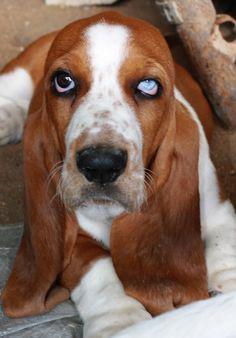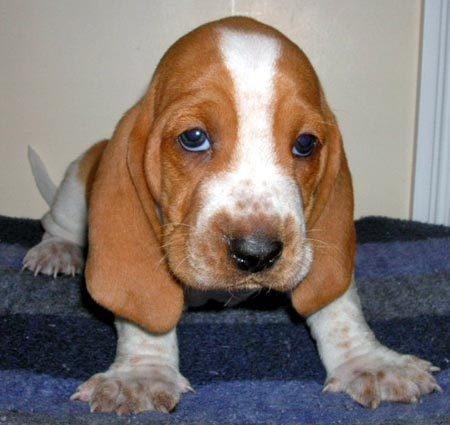The first image is the image on the left, the second image is the image on the right. For the images shown, is this caption "There are three dogs that are not running." true? Answer yes or no. No. The first image is the image on the left, the second image is the image on the right. Evaluate the accuracy of this statement regarding the images: "There is one hound in the left image and two hounds in the right image.". Is it true? Answer yes or no. No. 